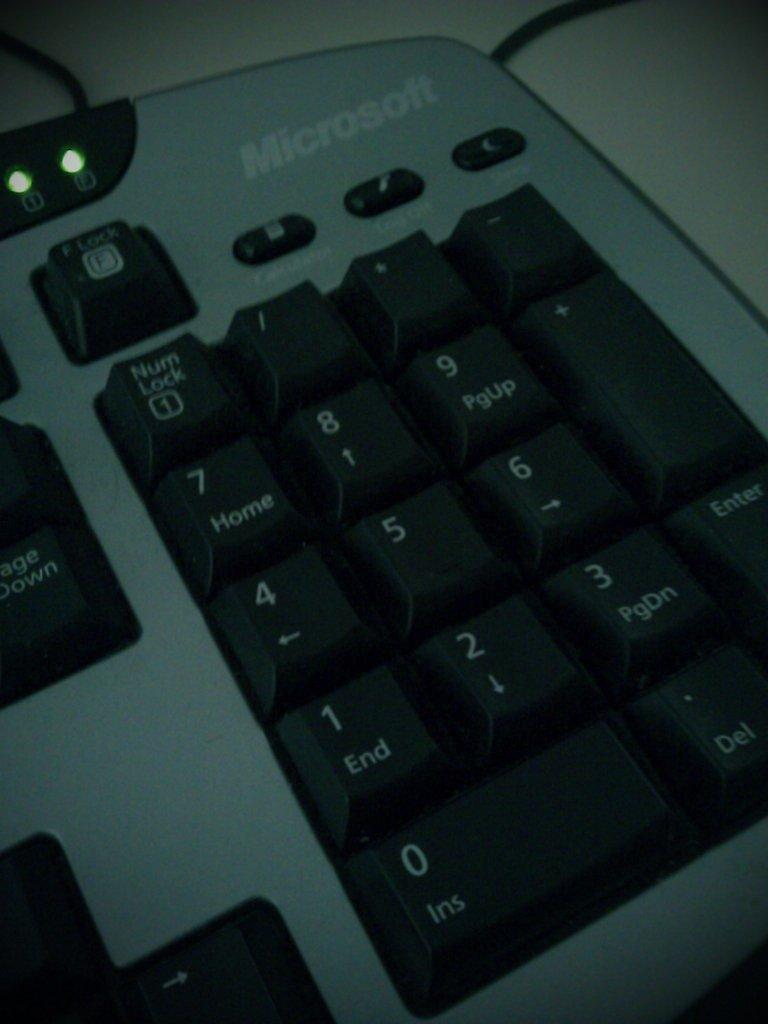Could you give a brief overview of what you see in this image? In the image there is a keyboard on a table. 